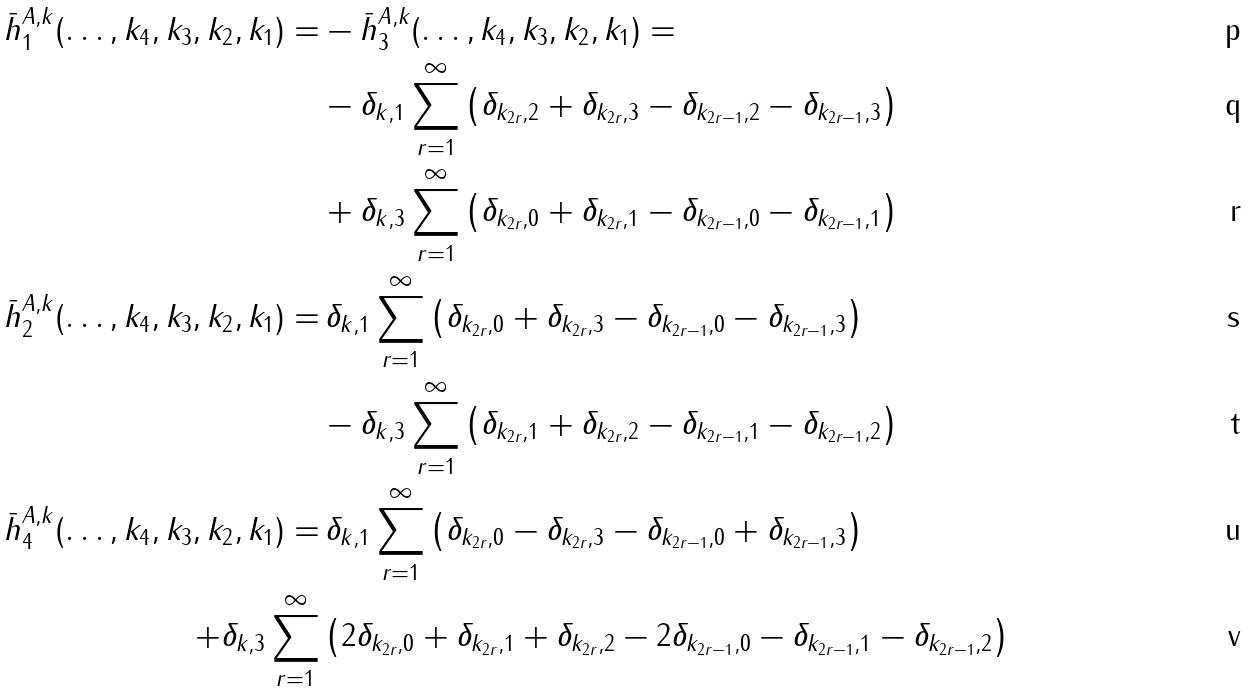<formula> <loc_0><loc_0><loc_500><loc_500>\bar { h } ^ { A , k } _ { 1 } ( \dots , k _ { 4 } , k _ { 3 } , k _ { 2 } , k _ { 1 } ) = & - \bar { h } _ { 3 } ^ { A , k } ( \dots , k _ { 4 } , k _ { 3 } , k _ { 2 } , k _ { 1 } ) = \\ & - \delta _ { k , 1 } \sum _ { r = 1 } ^ { \infty } \left ( \delta _ { k _ { 2 r } , 2 } + \delta _ { k _ { 2 r } , 3 } - \delta _ { k _ { 2 r - 1 } , 2 } - \delta _ { k _ { 2 r - 1 } , 3 } \right ) \\ & + \delta _ { k , 3 } \sum _ { r = 1 } ^ { \infty } \left ( \delta _ { k _ { 2 r } , 0 } + \delta _ { k _ { 2 r } , 1 } - \delta _ { k _ { 2 r - 1 } , 0 } - \delta _ { k _ { 2 r - 1 } , 1 } \right ) \\ \bar { h } ^ { A , k } _ { 2 } ( \dots , k _ { 4 } , k _ { 3 } , k _ { 2 } , k _ { 1 } ) = & \, \delta _ { k , 1 } \sum _ { r = 1 } ^ { \infty } \left ( \delta _ { k _ { 2 r } , 0 } + \delta _ { k _ { 2 r } , 3 } - \delta _ { k _ { 2 r - 1 } , 0 } - \delta _ { k _ { 2 r - 1 } , 3 } \right ) \\ & - \delta _ { k , 3 } \sum _ { r = 1 } ^ { \infty } \left ( \delta _ { k _ { 2 r } , 1 } + \delta _ { k _ { 2 r } , 2 } - \delta _ { k _ { 2 r - 1 } , 1 } - \delta _ { k _ { 2 r - 1 } , 2 } \right ) \\ \bar { h } ^ { A , k } _ { 4 } ( \dots , k _ { 4 } , k _ { 3 } , k _ { 2 } , k _ { 1 } ) = & \, \delta _ { k , 1 } \sum _ { r = 1 } ^ { \infty } \left ( \delta _ { k _ { 2 r } , 0 } - \delta _ { k _ { 2 r } , 3 } - \delta _ { k _ { 2 r - 1 } , 0 } + \delta _ { k _ { 2 r - 1 } , 3 } \right ) \\ + \delta _ { k , 3 } \sum _ { r = 1 } ^ { \infty } & \left ( 2 \delta _ { k _ { 2 r } , 0 } + \delta _ { k _ { 2 r } , 1 } + \delta _ { k _ { 2 r } , 2 } - 2 \delta _ { k _ { 2 r - 1 } , 0 } - \delta _ { k _ { 2 r - 1 } , 1 } - \delta _ { k _ { 2 r - 1 } , 2 } \right )</formula> 